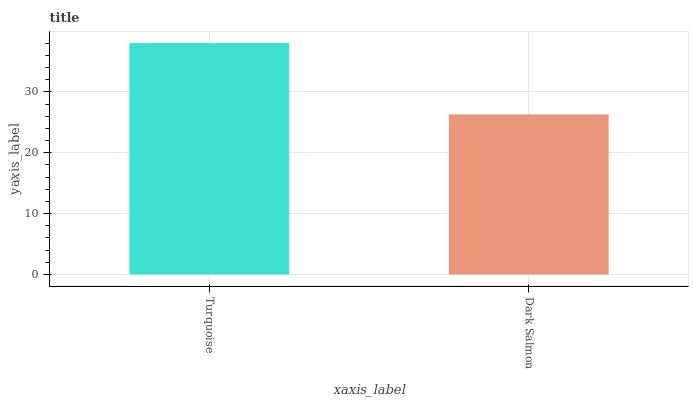Is Dark Salmon the minimum?
Answer yes or no. Yes. Is Turquoise the maximum?
Answer yes or no. Yes. Is Dark Salmon the maximum?
Answer yes or no. No. Is Turquoise greater than Dark Salmon?
Answer yes or no. Yes. Is Dark Salmon less than Turquoise?
Answer yes or no. Yes. Is Dark Salmon greater than Turquoise?
Answer yes or no. No. Is Turquoise less than Dark Salmon?
Answer yes or no. No. Is Turquoise the high median?
Answer yes or no. Yes. Is Dark Salmon the low median?
Answer yes or no. Yes. Is Dark Salmon the high median?
Answer yes or no. No. Is Turquoise the low median?
Answer yes or no. No. 